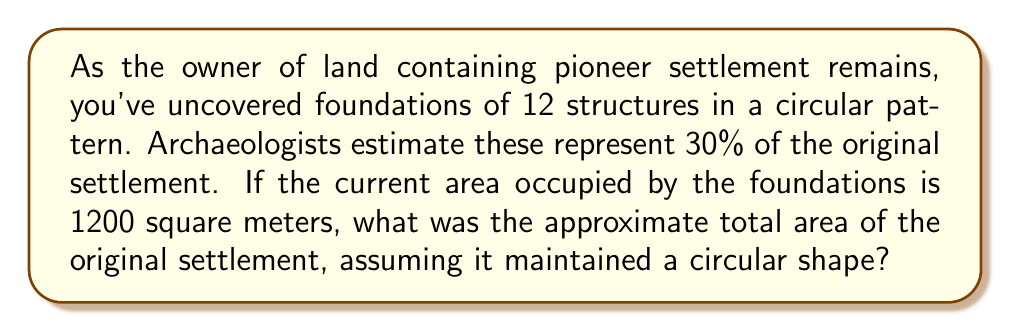Can you answer this question? Let's approach this step-by-step:

1) First, we need to understand what we know:
   - 12 structures represent 30% of the original settlement
   - The area of these 12 structures is 1200 square meters
   - The settlement maintained a circular shape

2) Let's calculate the total number of structures in the original settlement:
   $$ \frac{12}{0.30} = 40 \text{ structures} $$

3) Now, we need to find out how much larger the original settlement was:
   $$ \frac{40}{12} = \frac{10}{3} \approx 3.33 \text{ times larger} $$

4) Since the settlement is circular, the area scales with the square of the radius. If the number of structures is 3.33 times larger, the area will be:
   $$ 3.33^2 \approx 11.11 \text{ times larger} $$

5) Now we can calculate the total area:
   $$ 1200 \text{ m}^2 \times 11.11 = 13,332 \text{ m}^2 $$

Therefore, the original settlement occupied approximately 13,332 square meters.
Answer: 13,332 square meters 